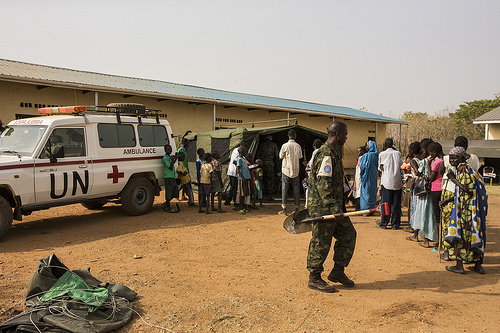<image>
Is the tarp under the wheel? No. The tarp is not positioned under the wheel. The vertical relationship between these objects is different. Is there a car behind the man? Yes. From this viewpoint, the car is positioned behind the man, with the man partially or fully occluding the car. Is there a van in front of the man? No. The van is not in front of the man. The spatial positioning shows a different relationship between these objects. 